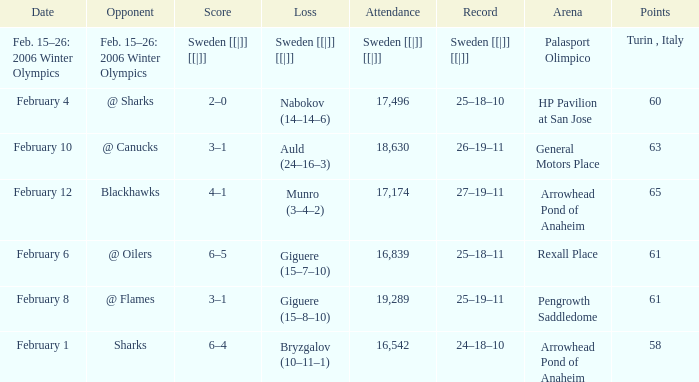What were the points on February 10? 63.0. 